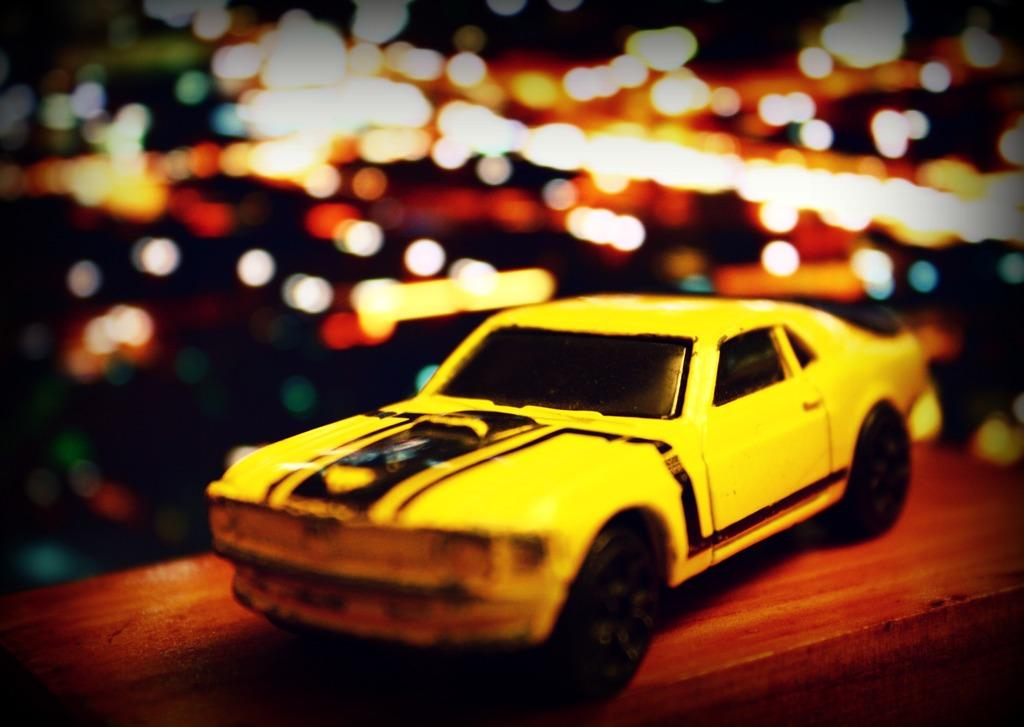What is the main object in the image? There is a toy car in the image. Can you describe the background of the image? The background of the image is blurry. Where is the garden located in the image? There is no garden present in the image; it only features a toy car and a blurry background. 